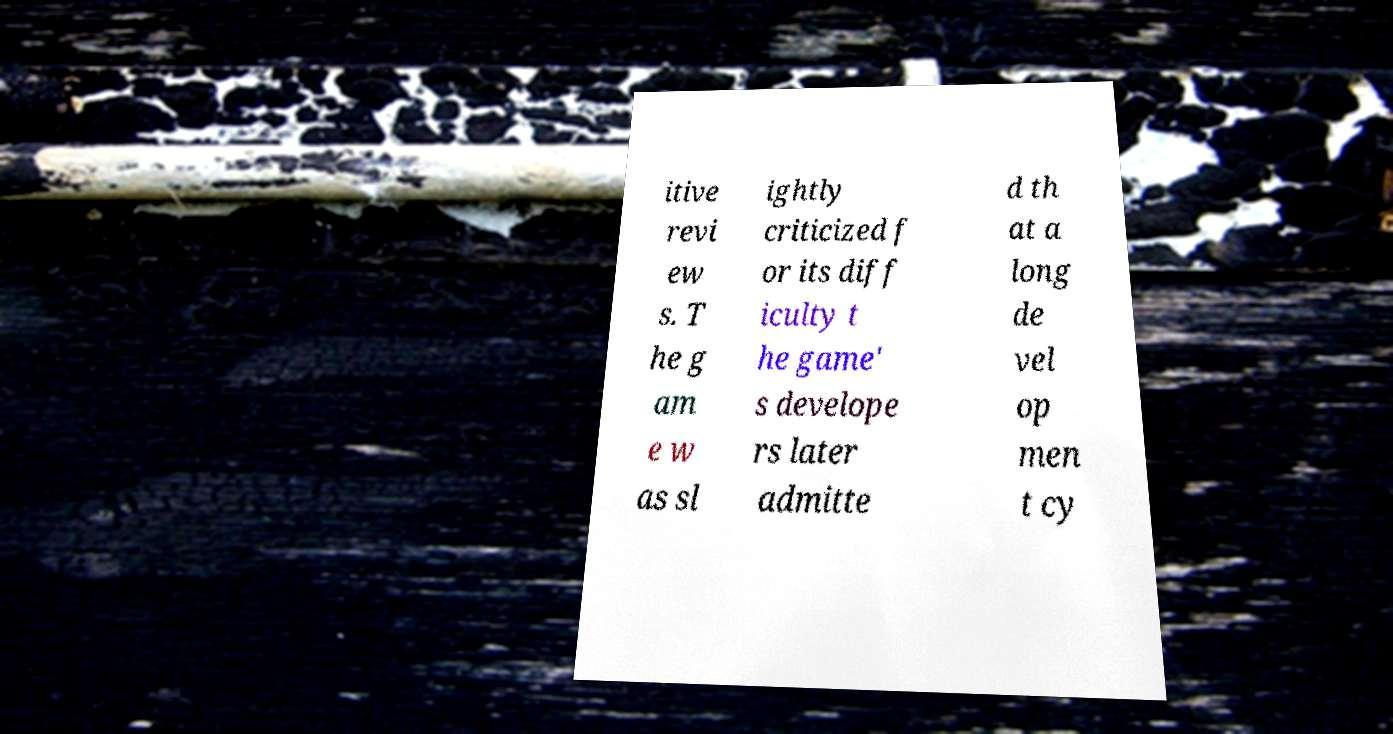Could you assist in decoding the text presented in this image and type it out clearly? itive revi ew s. T he g am e w as sl ightly criticized f or its diff iculty t he game' s develope rs later admitte d th at a long de vel op men t cy 